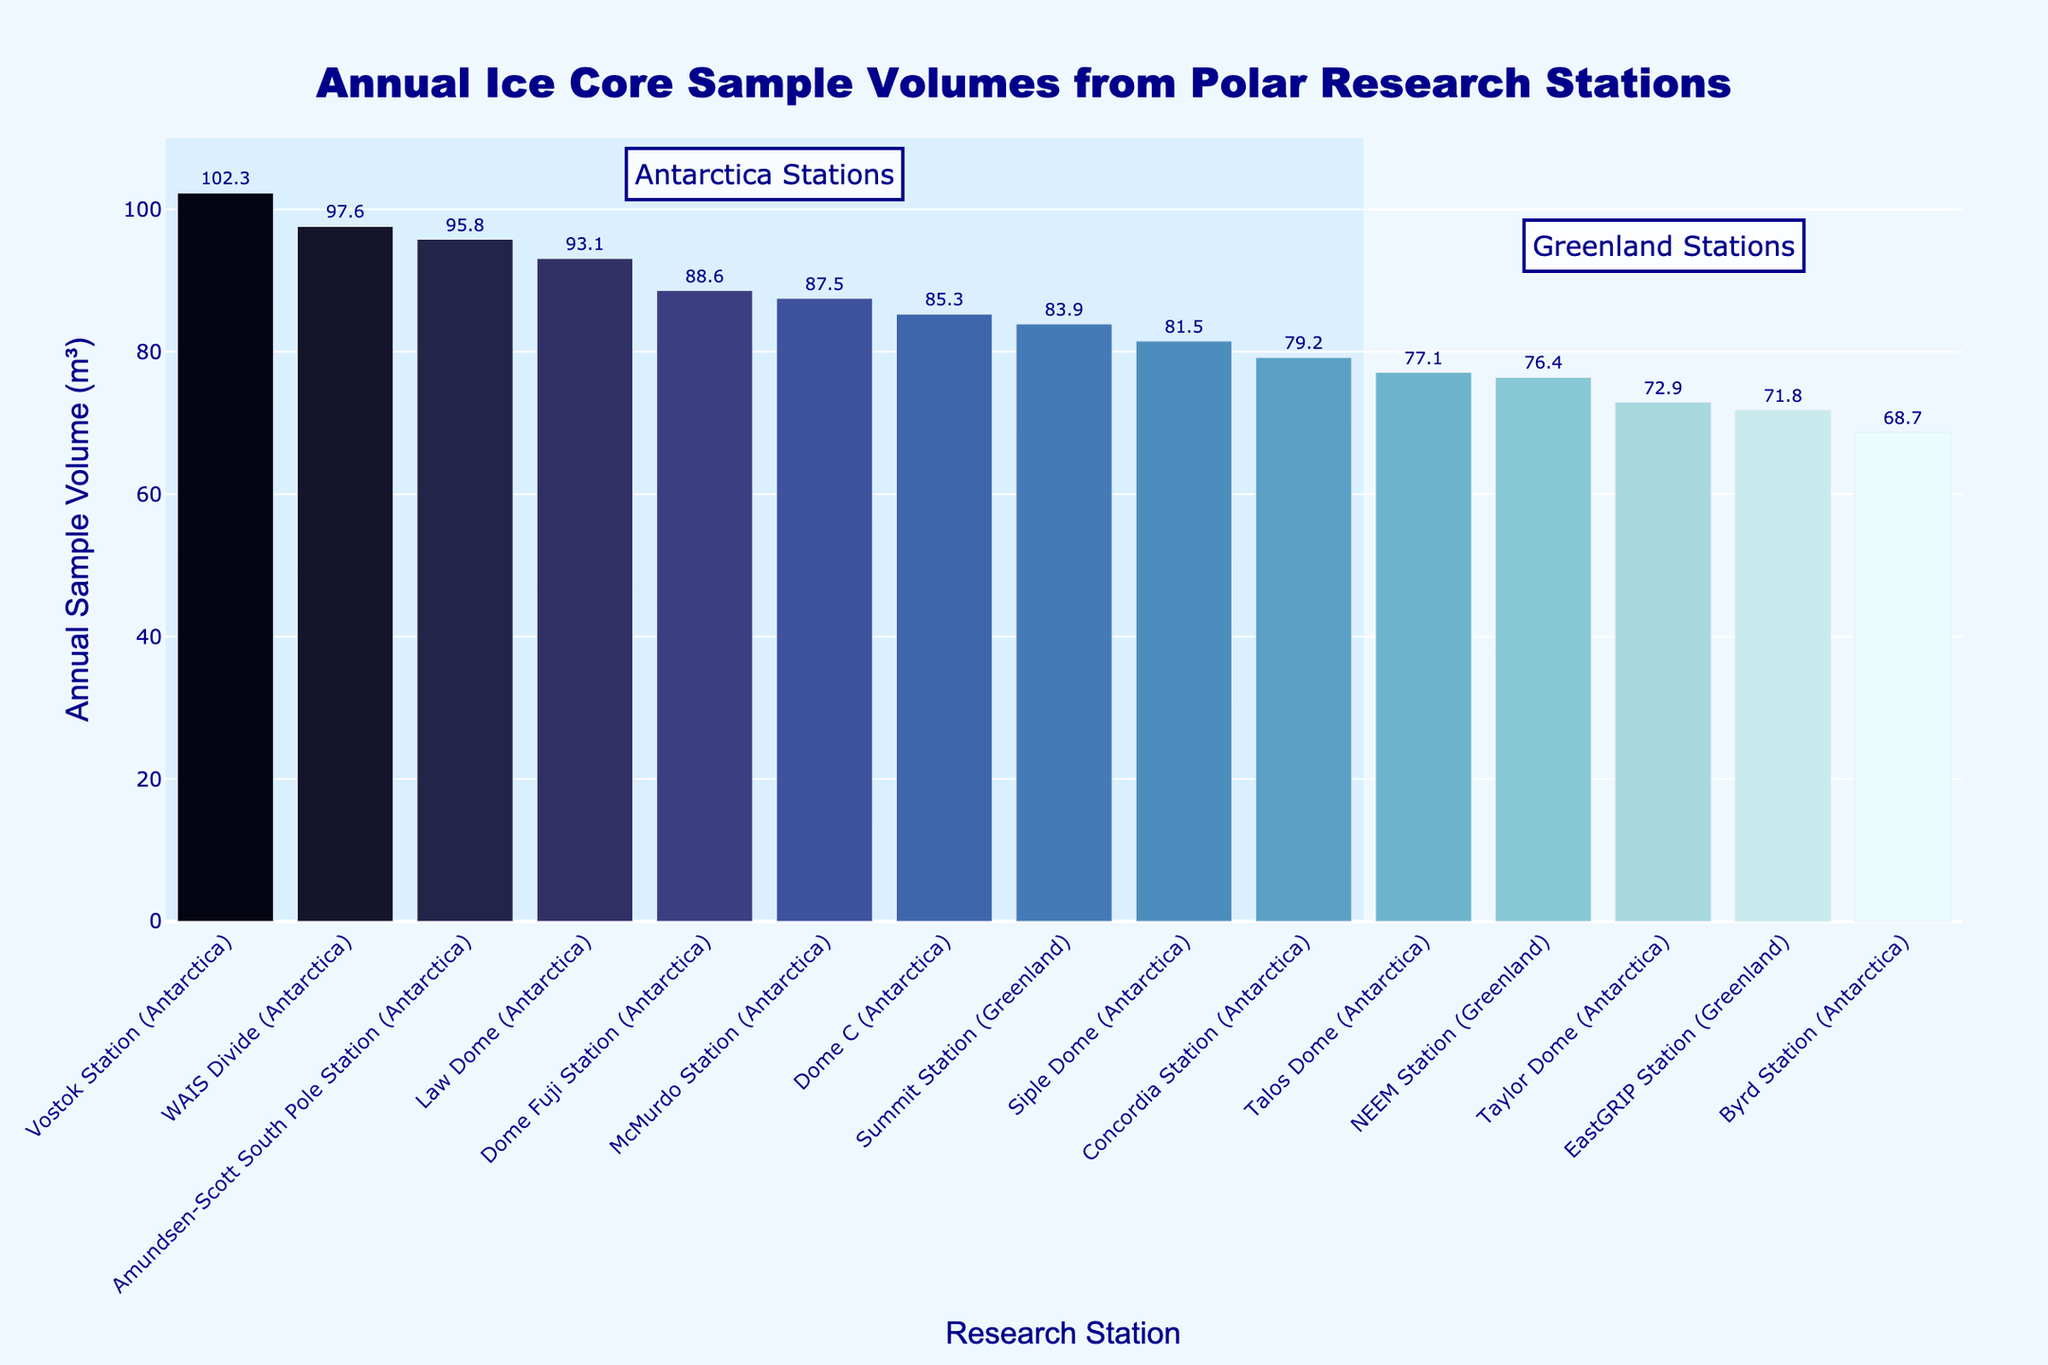What is the total annual ice core sample volume of all stations combined? Sum the annual ice core sample volumes for all listed stations (87.5 + 102.3 + 95.8 + 79.2 + 88.6 + 76.4 + 83.9 + 71.8 + 68.7 + 93.1 + 81.5 + 97.6 + 85.3 + 72.9 + 77.1) to get the total volume.
Answer: 1281.7 m³ Which station has the highest annual ice core sample volume? Look for the bar with the highest value in the chart. Vostok Station has the highest bar.
Answer: Vostok Station What's the difference in annual ice core sample volume between Vostok Station and EastGRIP Station? Identify the volumes of Vostok Station (102.3 m³) and EastGRIP Station (71.8 m³) and subtract the latter from the former (102.3 - 71.8).
Answer: 30.5 m³ Which station collects more ice core samples annually: McMurdo Station or Dome Fuji Station? Compare the heights of the bars for McMurdo Station (87.5 m³) and Dome Fuji Station (88.6 m³); Dome Fuji's bar is slightly higher.
Answer: Dome Fuji Station What is the average annual ice core sample volume of the stations in Antarctica? Sum the volumes of all Antarctica stations (87.5 + 102.3 + 95.8 + 79.2 + 88.6 + 68.7 + 93.1 + 81.5 + 97.6 + 85.3 + 72.9 + 77.1) and divide by the number of stations (12).
Answer: 85.1 m³ How many stations have an annual ice core sample volume greater than 90 m³? Count the number of bars with heights greater than 90 m³. The stations are Vostok, Amundsen-Scott, Law Dome, and WAIS Divide.
Answer: 4 What is the median annual ice core sample volume for all research stations? Arrange all sample volumes in ascending order and find the middle value. The volumes are: (68.7, 71.8, 72.9, 76.4, 77.1, 79.2, 81.5, 83.9, 85.3, 87.5, 88.6, 93.1, 95.8, 97.6, 102.3). The median is the 8th value.
Answer: 83.9 m³ Which station has the lowest annual ice core sample volume and what is its volume? Identify the bar with the lowest height, which is Byrd Station, and note the volume.
Answer: Byrd Station, 68.7 m³ What is the difference between the highest and lowest annual ice core sample volumes? Subtract the volume of the station with the lowest value (Byrd Station, 68.7 m³) from the highest value (Vostok Station, 102.3 m³).
Answer: 33.6 m³ How does the ice core sample collection volume from Summit Station compare to Siple Dome? Compare the heights of the bars for Summit Station (83.9 m³) and Siple Dome (81.5 m³); Summit Station's bar is slightly higher.
Answer: Summit Station collects more than Siple Dome 